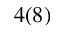Convert formula to latex. <formula><loc_0><loc_0><loc_500><loc_500>4 ( 8 )</formula> 